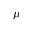Convert formula to latex. <formula><loc_0><loc_0><loc_500><loc_500>\mu</formula> 